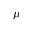Convert formula to latex. <formula><loc_0><loc_0><loc_500><loc_500>\mu</formula> 